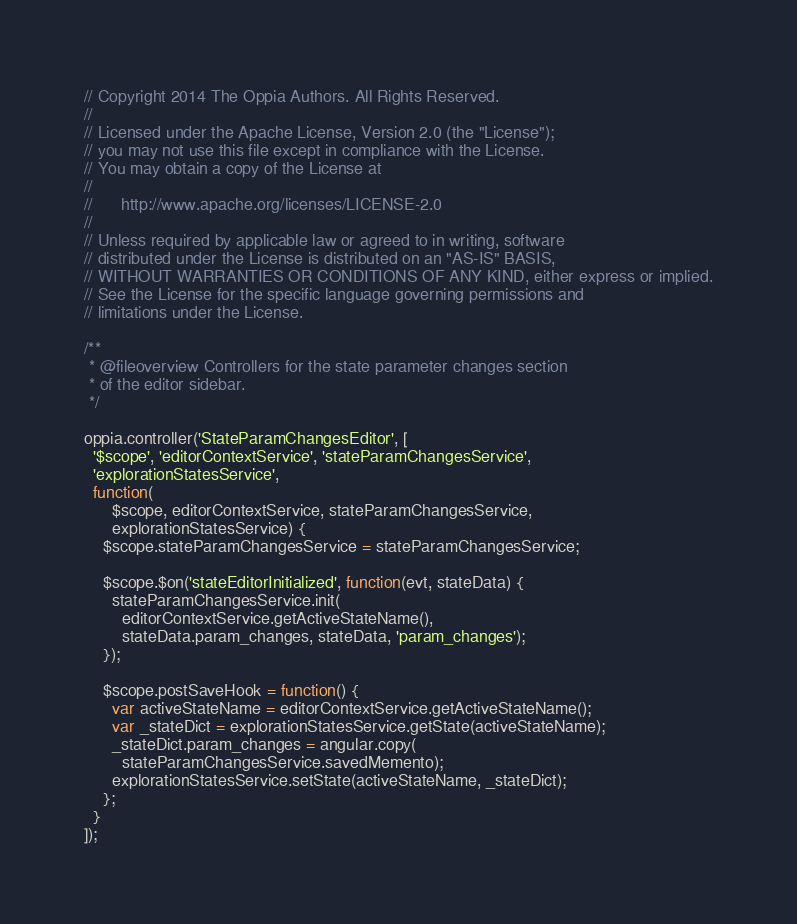<code> <loc_0><loc_0><loc_500><loc_500><_JavaScript_>// Copyright 2014 The Oppia Authors. All Rights Reserved.
//
// Licensed under the Apache License, Version 2.0 (the "License");
// you may not use this file except in compliance with the License.
// You may obtain a copy of the License at
//
//      http://www.apache.org/licenses/LICENSE-2.0
//
// Unless required by applicable law or agreed to in writing, software
// distributed under the License is distributed on an "AS-IS" BASIS,
// WITHOUT WARRANTIES OR CONDITIONS OF ANY KIND, either express or implied.
// See the License for the specific language governing permissions and
// limitations under the License.

/**
 * @fileoverview Controllers for the state parameter changes section
 * of the editor sidebar.
 */

oppia.controller('StateParamChangesEditor', [
  '$scope', 'editorContextService', 'stateParamChangesService',
  'explorationStatesService',
  function(
      $scope, editorContextService, stateParamChangesService,
      explorationStatesService) {
    $scope.stateParamChangesService = stateParamChangesService;

    $scope.$on('stateEditorInitialized', function(evt, stateData) {
      stateParamChangesService.init(
        editorContextService.getActiveStateName(),
        stateData.param_changes, stateData, 'param_changes');
    });

    $scope.postSaveHook = function() {
      var activeStateName = editorContextService.getActiveStateName();
      var _stateDict = explorationStatesService.getState(activeStateName);
      _stateDict.param_changes = angular.copy(
        stateParamChangesService.savedMemento);
      explorationStatesService.setState(activeStateName, _stateDict);
    };
  }
]);
</code> 